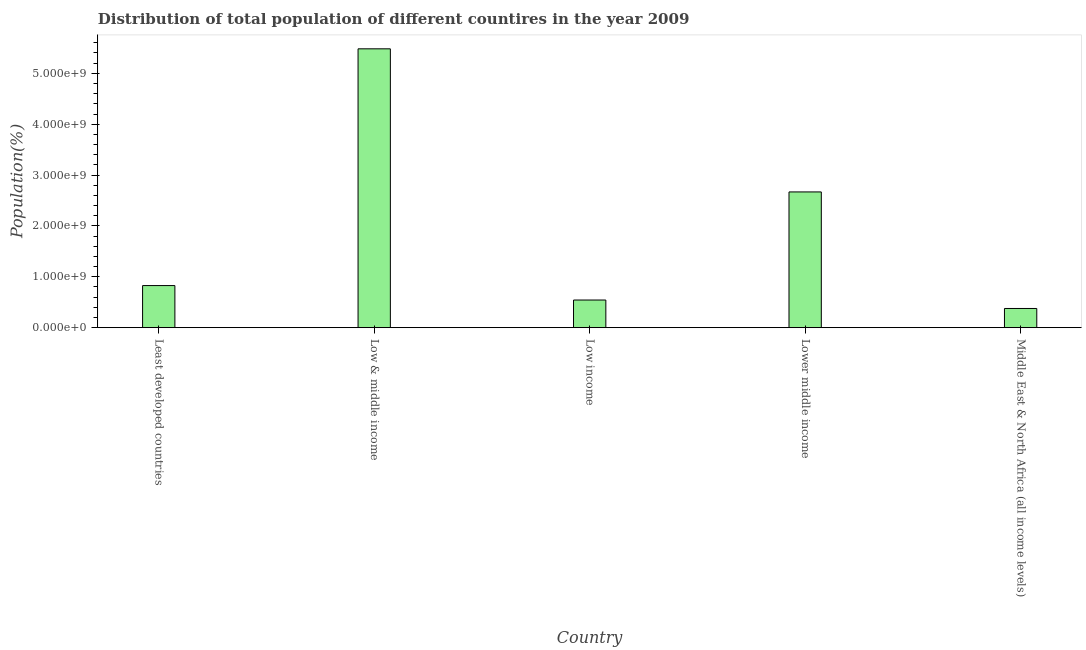What is the title of the graph?
Ensure brevity in your answer.  Distribution of total population of different countires in the year 2009. What is the label or title of the X-axis?
Offer a very short reply. Country. What is the label or title of the Y-axis?
Keep it short and to the point. Population(%). What is the population in Low income?
Offer a very short reply. 5.44e+08. Across all countries, what is the maximum population?
Your answer should be very brief. 5.48e+09. Across all countries, what is the minimum population?
Ensure brevity in your answer.  3.77e+08. In which country was the population maximum?
Provide a short and direct response. Low & middle income. In which country was the population minimum?
Your answer should be very brief. Middle East & North Africa (all income levels). What is the sum of the population?
Your answer should be very brief. 9.90e+09. What is the difference between the population in Least developed countries and Middle East & North Africa (all income levels)?
Provide a short and direct response. 4.50e+08. What is the average population per country?
Ensure brevity in your answer.  1.98e+09. What is the median population?
Keep it short and to the point. 8.27e+08. What is the ratio of the population in Least developed countries to that in Middle East & North Africa (all income levels)?
Ensure brevity in your answer.  2.19. Is the population in Least developed countries less than that in Middle East & North Africa (all income levels)?
Your answer should be compact. No. Is the difference between the population in Least developed countries and Lower middle income greater than the difference between any two countries?
Your answer should be very brief. No. What is the difference between the highest and the second highest population?
Offer a very short reply. 2.81e+09. What is the difference between the highest and the lowest population?
Give a very brief answer. 5.10e+09. How many bars are there?
Ensure brevity in your answer.  5. What is the difference between two consecutive major ticks on the Y-axis?
Offer a very short reply. 1.00e+09. What is the Population(%) in Least developed countries?
Make the answer very short. 8.27e+08. What is the Population(%) of Low & middle income?
Provide a short and direct response. 5.48e+09. What is the Population(%) in Low income?
Your response must be concise. 5.44e+08. What is the Population(%) in Lower middle income?
Offer a very short reply. 2.67e+09. What is the Population(%) in Middle East & North Africa (all income levels)?
Your answer should be compact. 3.77e+08. What is the difference between the Population(%) in Least developed countries and Low & middle income?
Keep it short and to the point. -4.65e+09. What is the difference between the Population(%) in Least developed countries and Low income?
Make the answer very short. 2.84e+08. What is the difference between the Population(%) in Least developed countries and Lower middle income?
Provide a succinct answer. -1.84e+09. What is the difference between the Population(%) in Least developed countries and Middle East & North Africa (all income levels)?
Provide a succinct answer. 4.50e+08. What is the difference between the Population(%) in Low & middle income and Low income?
Provide a short and direct response. 4.94e+09. What is the difference between the Population(%) in Low & middle income and Lower middle income?
Your answer should be very brief. 2.81e+09. What is the difference between the Population(%) in Low & middle income and Middle East & North Africa (all income levels)?
Give a very brief answer. 5.10e+09. What is the difference between the Population(%) in Low income and Lower middle income?
Offer a very short reply. -2.12e+09. What is the difference between the Population(%) in Low income and Middle East & North Africa (all income levels)?
Make the answer very short. 1.66e+08. What is the difference between the Population(%) in Lower middle income and Middle East & North Africa (all income levels)?
Keep it short and to the point. 2.29e+09. What is the ratio of the Population(%) in Least developed countries to that in Low & middle income?
Keep it short and to the point. 0.15. What is the ratio of the Population(%) in Least developed countries to that in Low income?
Your answer should be compact. 1.52. What is the ratio of the Population(%) in Least developed countries to that in Lower middle income?
Your answer should be very brief. 0.31. What is the ratio of the Population(%) in Least developed countries to that in Middle East & North Africa (all income levels)?
Ensure brevity in your answer.  2.19. What is the ratio of the Population(%) in Low & middle income to that in Low income?
Ensure brevity in your answer.  10.09. What is the ratio of the Population(%) in Low & middle income to that in Lower middle income?
Your answer should be compact. 2.05. What is the ratio of the Population(%) in Low & middle income to that in Middle East & North Africa (all income levels)?
Your response must be concise. 14.54. What is the ratio of the Population(%) in Low income to that in Lower middle income?
Make the answer very short. 0.2. What is the ratio of the Population(%) in Low income to that in Middle East & North Africa (all income levels)?
Ensure brevity in your answer.  1.44. What is the ratio of the Population(%) in Lower middle income to that in Middle East & North Africa (all income levels)?
Give a very brief answer. 7.08. 